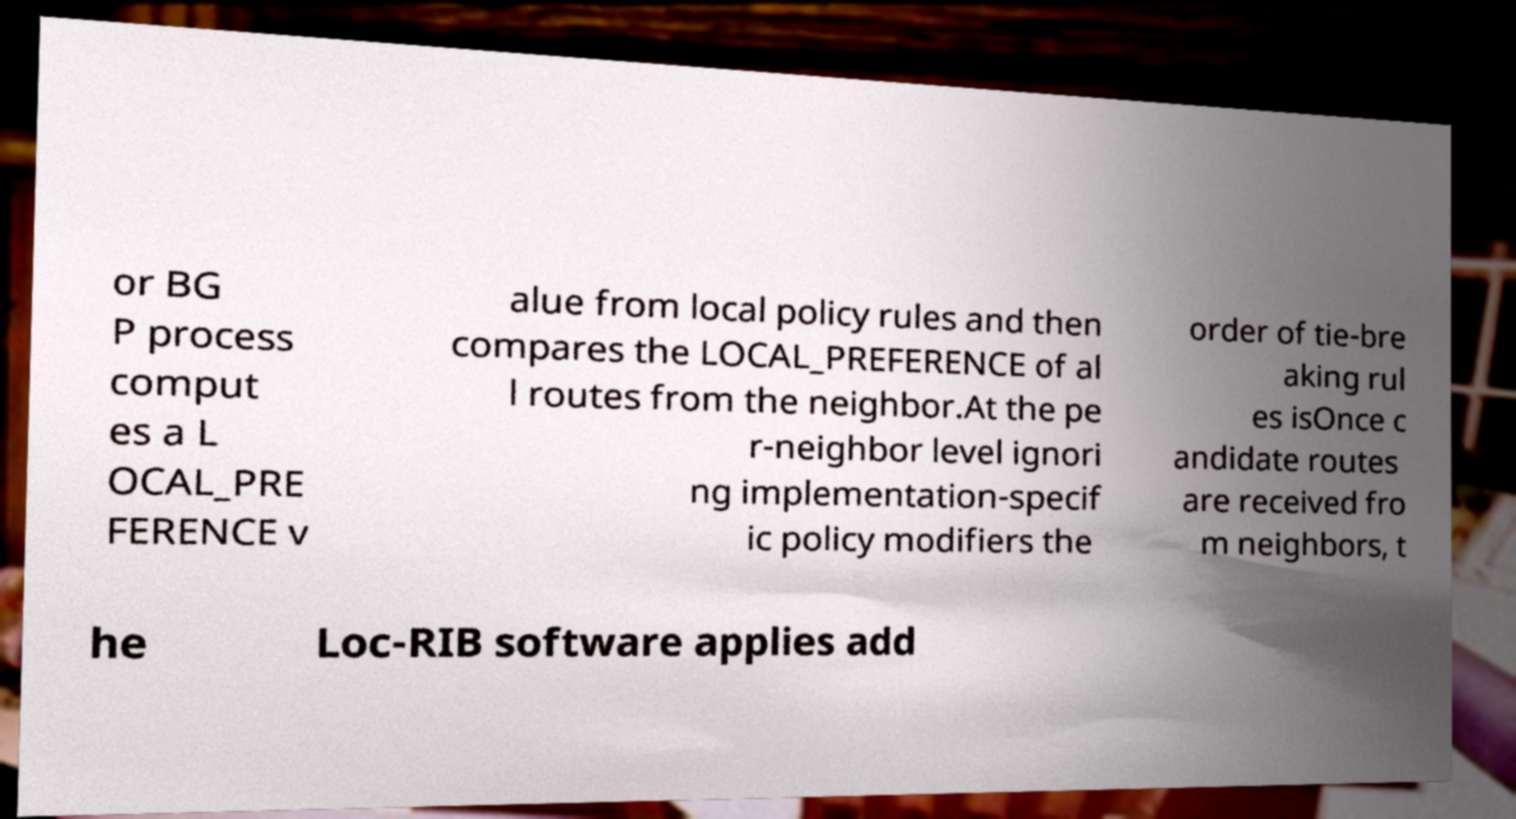Please identify and transcribe the text found in this image. or BG P process comput es a L OCAL_PRE FERENCE v alue from local policy rules and then compares the LOCAL_PREFERENCE of al l routes from the neighbor.At the pe r-neighbor level ignori ng implementation-specif ic policy modifiers the order of tie-bre aking rul es isOnce c andidate routes are received fro m neighbors, t he Loc-RIB software applies add 